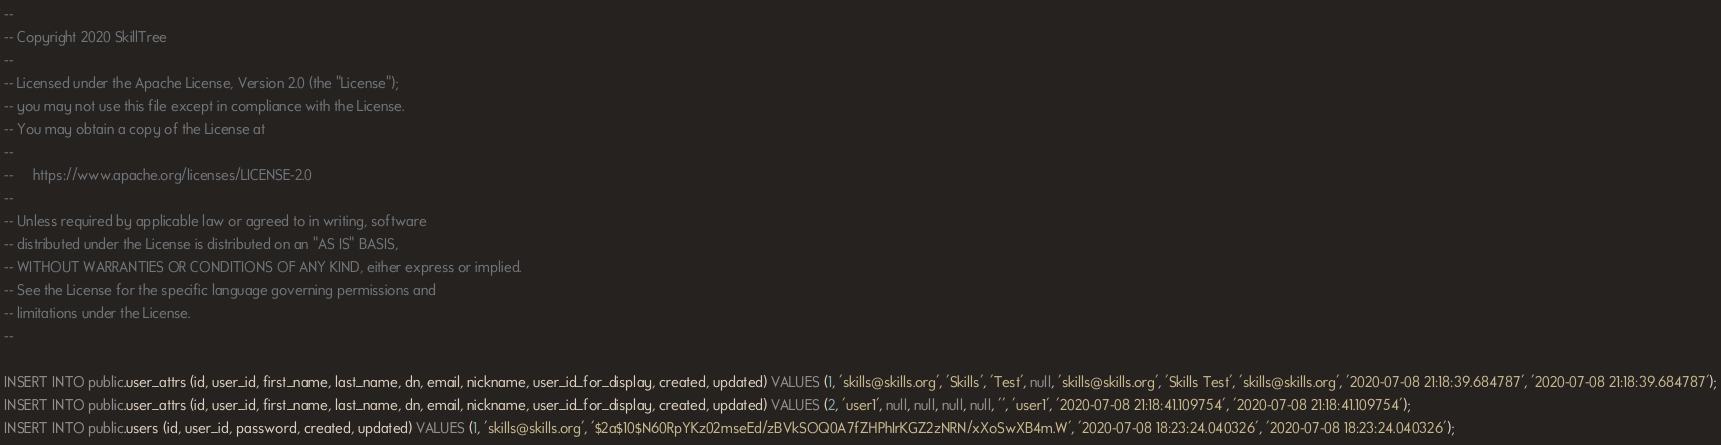Convert code to text. <code><loc_0><loc_0><loc_500><loc_500><_SQL_>--
-- Copyright 2020 SkillTree
--
-- Licensed under the Apache License, Version 2.0 (the "License");
-- you may not use this file except in compliance with the License.
-- You may obtain a copy of the License at
--
--     https://www.apache.org/licenses/LICENSE-2.0
--
-- Unless required by applicable law or agreed to in writing, software
-- distributed under the License is distributed on an "AS IS" BASIS,
-- WITHOUT WARRANTIES OR CONDITIONS OF ANY KIND, either express or implied.
-- See the License for the specific language governing permissions and
-- limitations under the License.
--

INSERT INTO public.user_attrs (id, user_id, first_name, last_name, dn, email, nickname, user_id_for_display, created, updated) VALUES (1, 'skills@skills.org', 'Skills', 'Test', null, 'skills@skills.org', 'Skills Test', 'skills@skills.org', '2020-07-08 21:18:39.684787', '2020-07-08 21:18:39.684787');
INSERT INTO public.user_attrs (id, user_id, first_name, last_name, dn, email, nickname, user_id_for_display, created, updated) VALUES (2, 'user1', null, null, null, null, '', 'user1', '2020-07-08 21:18:41.109754', '2020-07-08 21:18:41.109754');
INSERT INTO public.users (id, user_id, password, created, updated) VALUES (1, 'skills@skills.org', '$2a$10$N60RpYKz02mseEd/zBVkSOQ0A7fZHPhIrKGZ2zNRN/xXoSwXB4m.W', '2020-07-08 18:23:24.040326', '2020-07-08 18:23:24.040326');</code> 